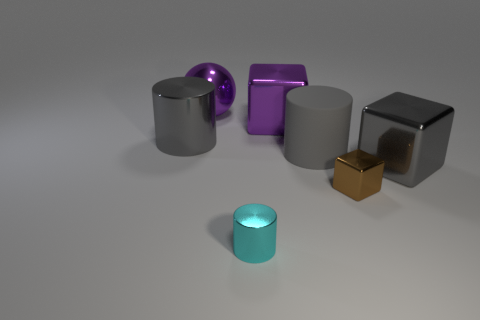How many gray cylinders must be subtracted to get 1 gray cylinders? 1 Subtract all big purple shiny blocks. How many blocks are left? 2 Subtract all cyan spheres. How many gray cylinders are left? 2 Subtract 1 blocks. How many blocks are left? 2 Add 1 red matte things. How many objects exist? 8 Subtract all spheres. How many objects are left? 6 Subtract all large purple spheres. Subtract all big cylinders. How many objects are left? 4 Add 3 tiny blocks. How many tiny blocks are left? 4 Add 1 big metallic things. How many big metallic things exist? 5 Subtract 1 cyan cylinders. How many objects are left? 6 